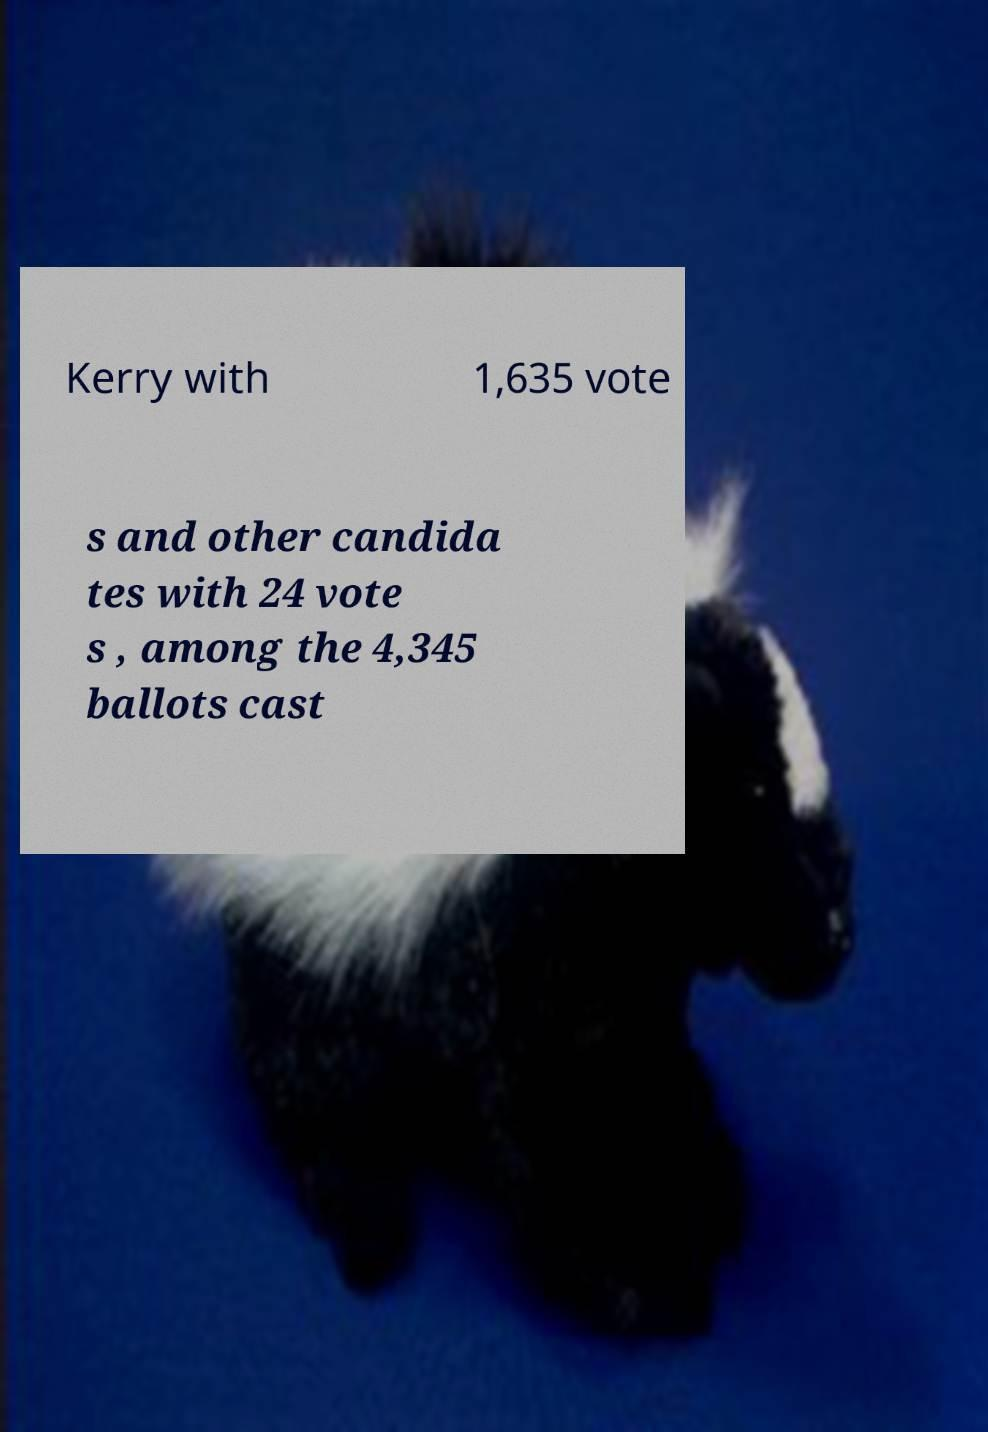For documentation purposes, I need the text within this image transcribed. Could you provide that? Kerry with 1,635 vote s and other candida tes with 24 vote s , among the 4,345 ballots cast 